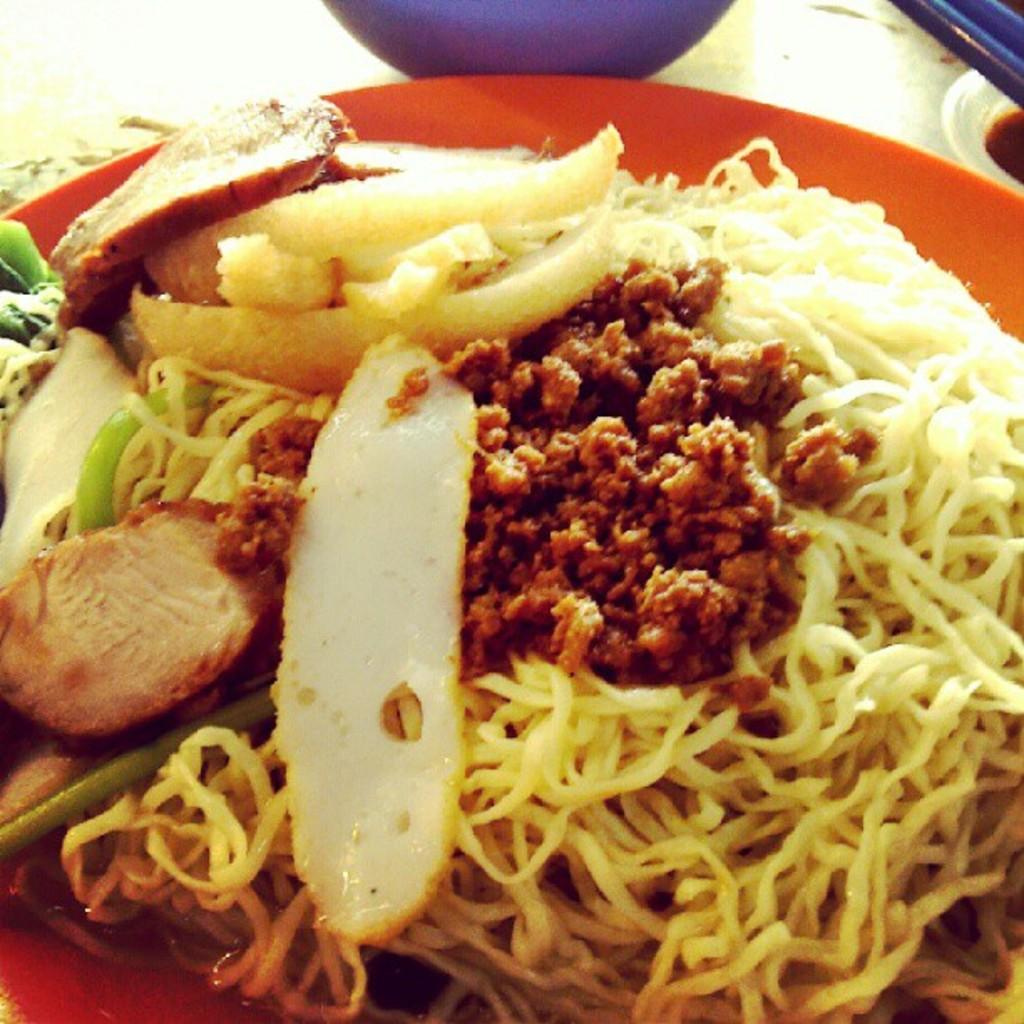What is the main subject of the image? There is a food item in the image. Where is the food item located? The food item is on a table. What type of vein is visible in the image? There is no vein visible in the image; it features a food item on a table. How does the butter contribute to the wealth of the person in the image? There is no person or butter present in the image, so it is not possible to determine any contribution to wealth. 